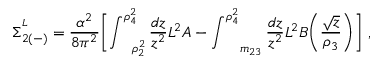<formula> <loc_0><loc_0><loc_500><loc_500>\Sigma _ { 2 ( - ) } ^ { ^ { L } } = \frac { \alpha ^ { 2 } } { 8 \pi ^ { 2 } } \left [ \int _ { \quad r h o _ { 2 } ^ { 2 } } ^ { \rho _ { 4 } ^ { 2 } } \frac { d z } { z ^ { 2 } } L ^ { 2 } A - \int _ { \quad m _ { 2 3 } } ^ { \rho _ { 4 } ^ { 2 } } \frac { d z } { z ^ { 2 } } L ^ { 2 } B \left ( \frac { \sqrt { z } } { \rho _ { 3 } } \right ) \right ] \ ,</formula> 